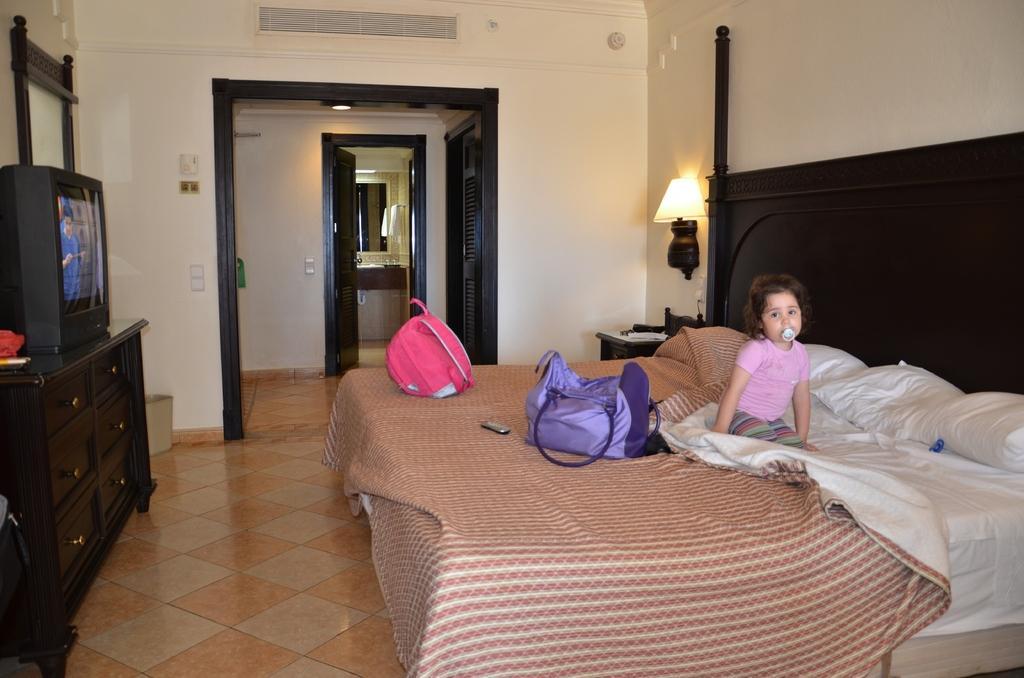How would you summarize this image in a sentence or two? In this picture there is a girl sitting on the bed, there is a blanket and pillows kept on the bed. There are also some bags, on to the right there is a television. 